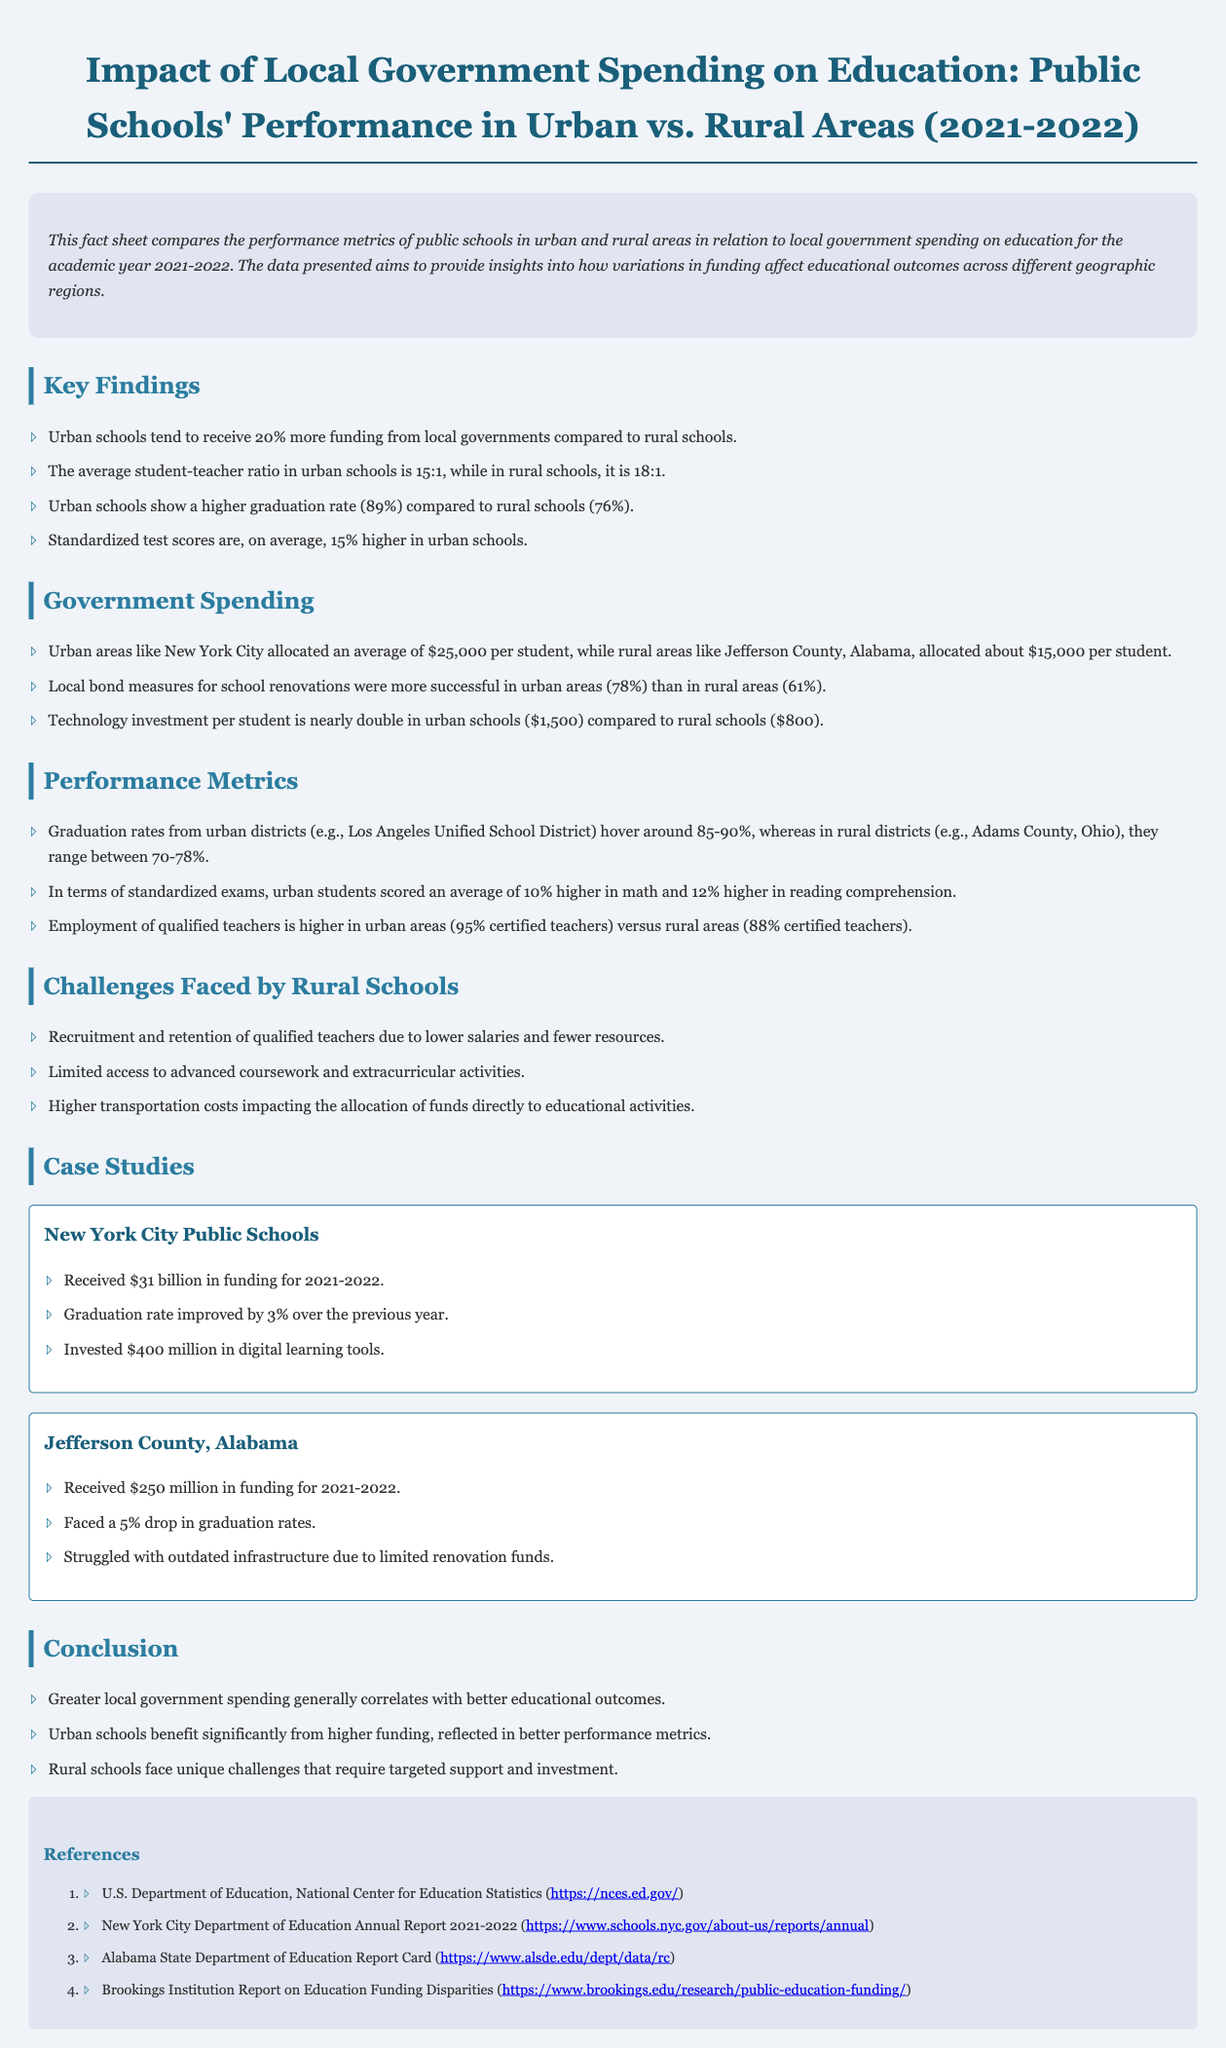What is the percentage difference in funding between urban and rural schools? Urban schools receive 20% more funding than rural schools.
Answer: 20% What is the average student-teacher ratio in urban schools? The average student-teacher ratio in urban schools is 15:1.
Answer: 15:1 What was the graduation rate for rural schools? The graduation rate for rural schools is 76%.
Answer: 76% How much is invested in technology per student in urban schools? Technology investment per student in urban schools is $1,500.
Answer: $1,500 What was the graduation rate for New York City Public Schools in 2021-2022? The graduation rate for New York City Public Schools improved by 3% over the previous year.
Answer: Improved by 3% What unique challenge do rural schools face regarding teacher recruitment? Rural schools face recruitment and retention challenges due to lower salaries and fewer resources.
Answer: Lower salaries In which area were local bond measures for school renovations more successful? Local bond measures were more successful in urban areas.
Answer: Urban areas What was the funding allocated for Jefferson County, Alabama? Jefferson County received $250 million in funding for 2021-2022.
Answer: $250 million What correlation is noted in the conclusion? Greater local government spending correlates with better educational outcomes.
Answer: Better educational outcomes 